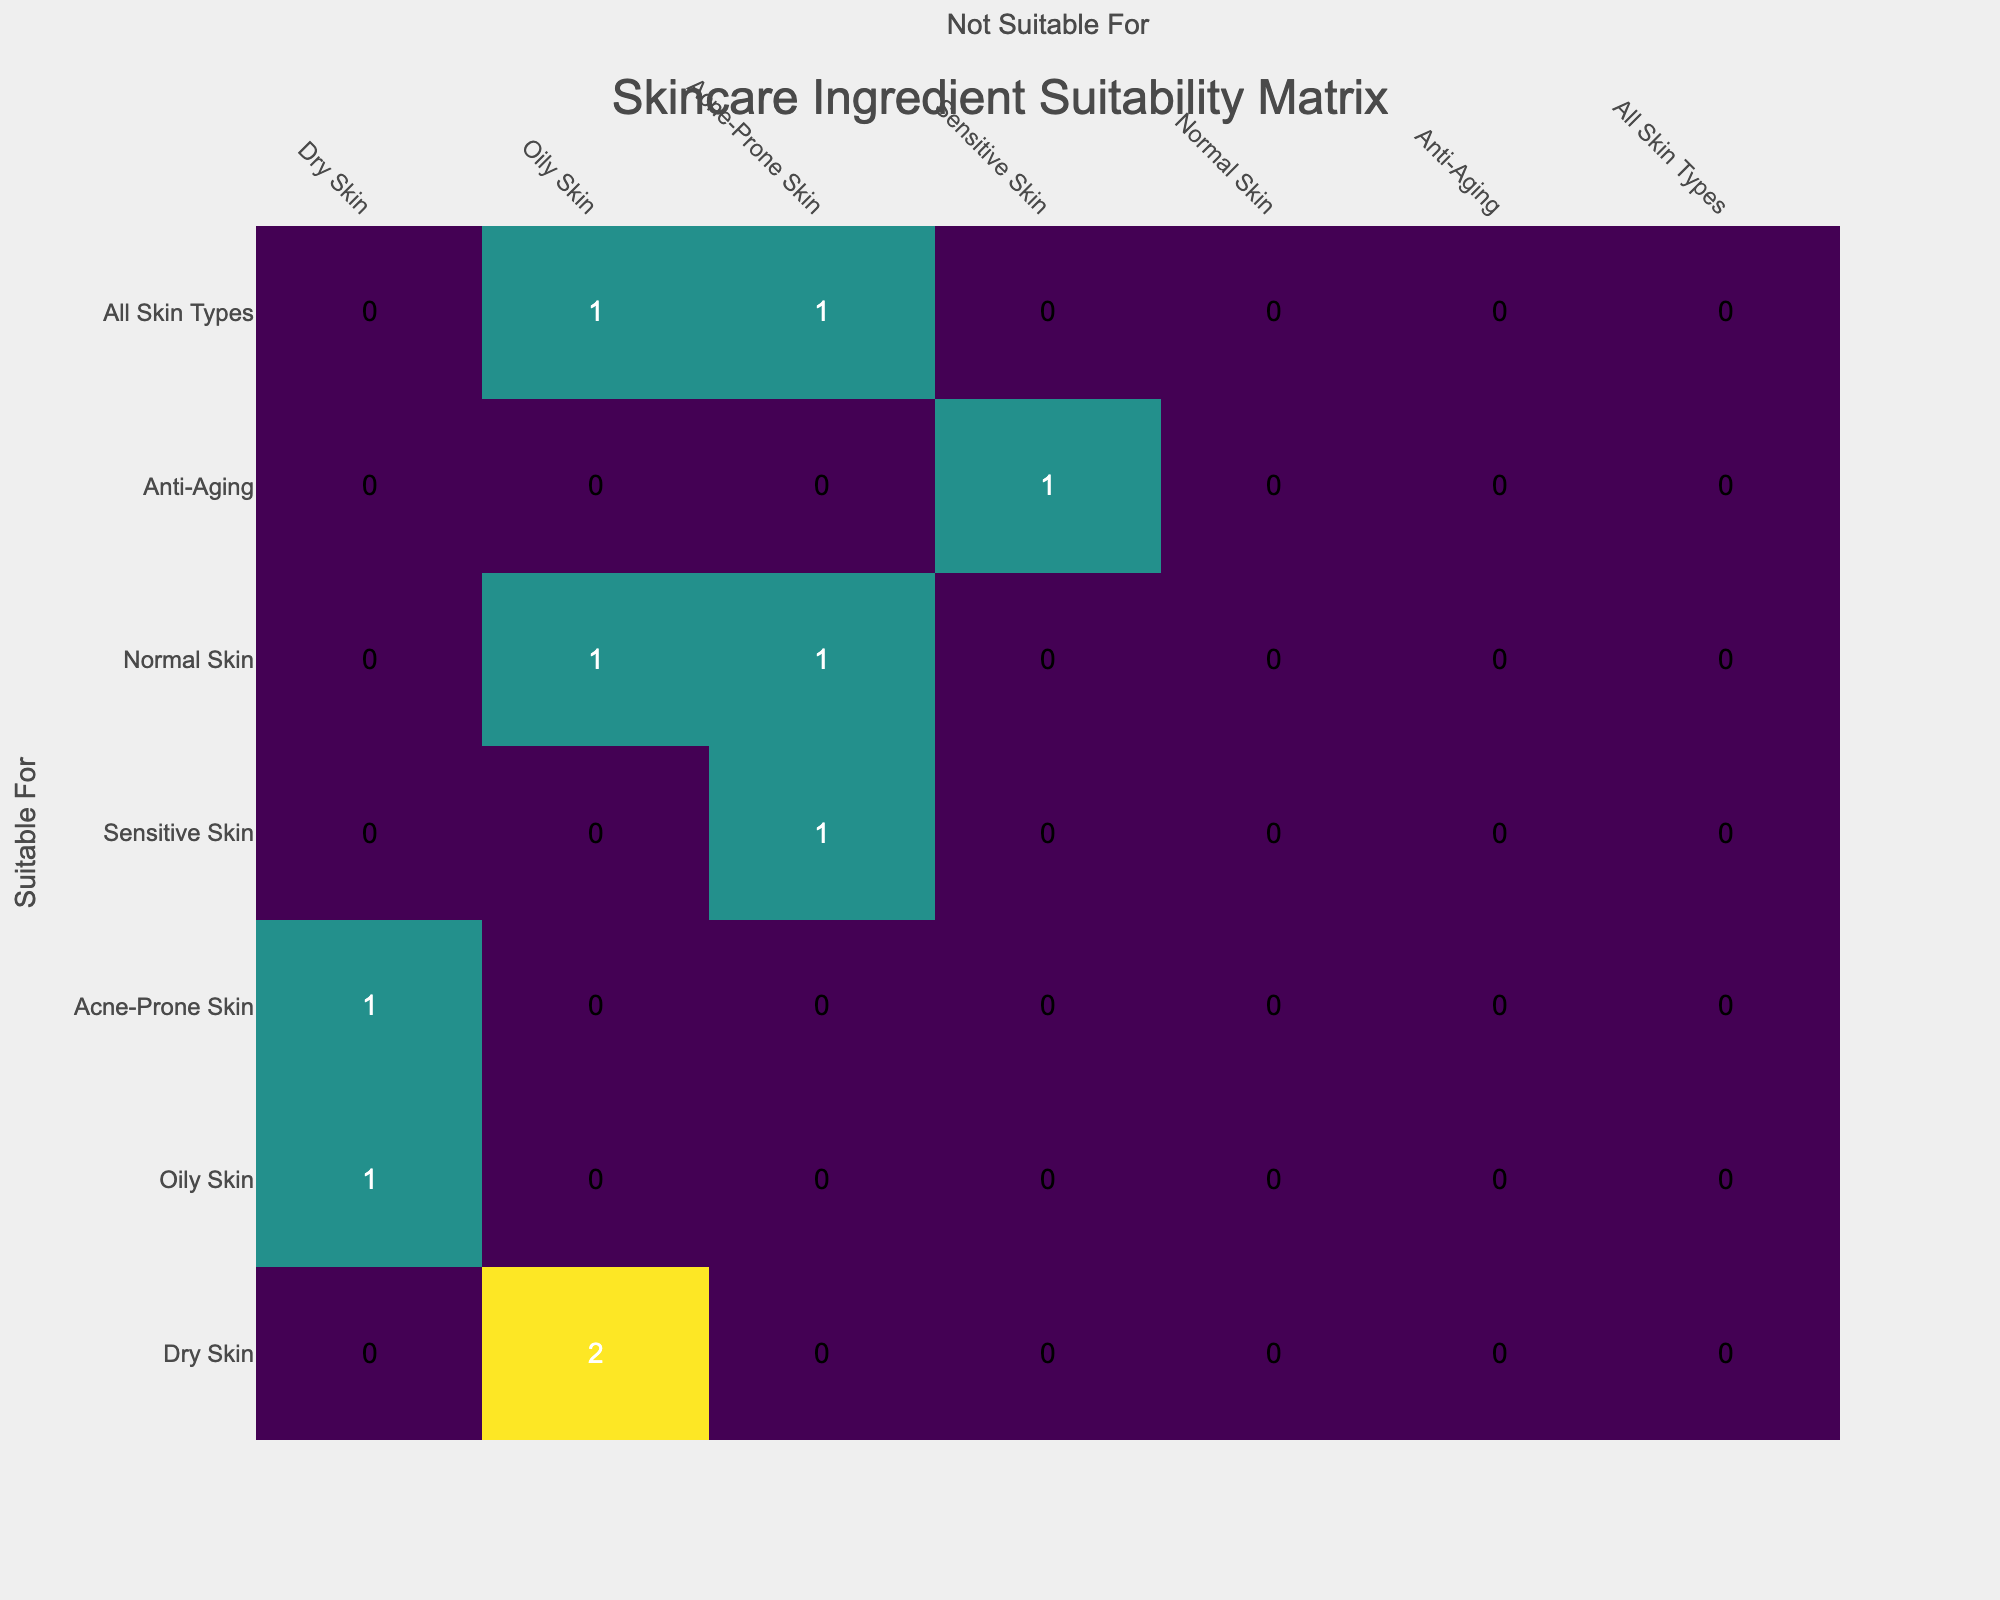What is the number of ingredients suitable for dry skin? In the table, the ingredients suitable for dry skin are Hyaluronic Acid (1), Lotus Flower (1), and Vitamin C (1). Adding these gives a total of 3.
Answer: 3 Which skin type has the highest number of ingredients that are not suitable for it? By looking at the matrix, we can see 'Oily Skin' has the highest number of not suitable ingredients with 4 counts (Hydration Drops, Renewing SA Cleanser, Bamba Cream).
Answer: Oily Skin Are there any ingredients that are suitable for all skin types? From the table, Kiehl's Hemp Seed Oil is the only ingredient that is suitable for all skin types, as indicated by it showing 'All Skin Types' in the Suitable column with no restrictions listed.
Answer: Yes How many ingredients are suitable for combination of dry and oily skin? Checking the matrix, we observe that there are 3 suitable ingredients for dry skin (1) which have counts against oily skin. Similarly, we check the not suitable for the combinations which are slightly tricky. Therefore, to be dry but not oily means ingredients i.e. (Hyaluronic Acid, Lotus Flower) are counted. So, the total is 3 - 2 = 1 suitable ones.
Answer: 1 Is there any ingredient suitable for both sensitive and acne-prone skin? The table reveals that Green Tea (Paula's Choice) is suitable for sensitive skin but noted as not suitable for acne-prone skin. Hence, there are no ingredients that fit both criteria.
Answer: No 